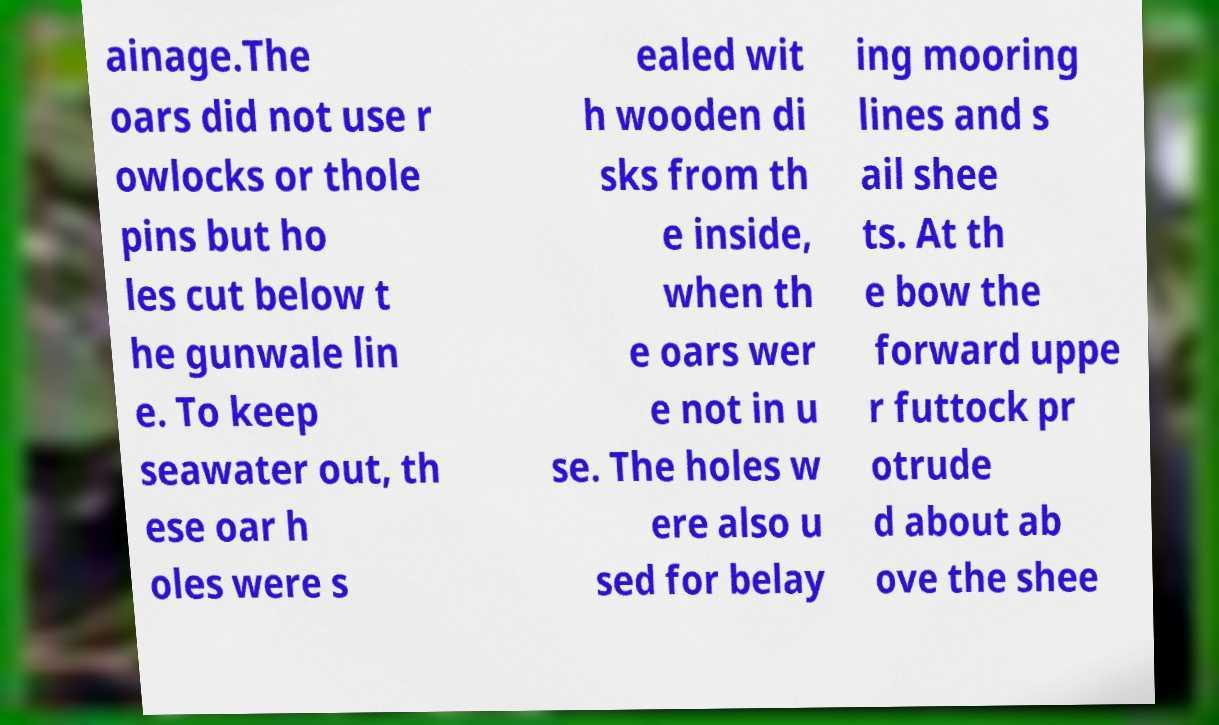Can you accurately transcribe the text from the provided image for me? ainage.The oars did not use r owlocks or thole pins but ho les cut below t he gunwale lin e. To keep seawater out, th ese oar h oles were s ealed wit h wooden di sks from th e inside, when th e oars wer e not in u se. The holes w ere also u sed for belay ing mooring lines and s ail shee ts. At th e bow the forward uppe r futtock pr otrude d about ab ove the shee 